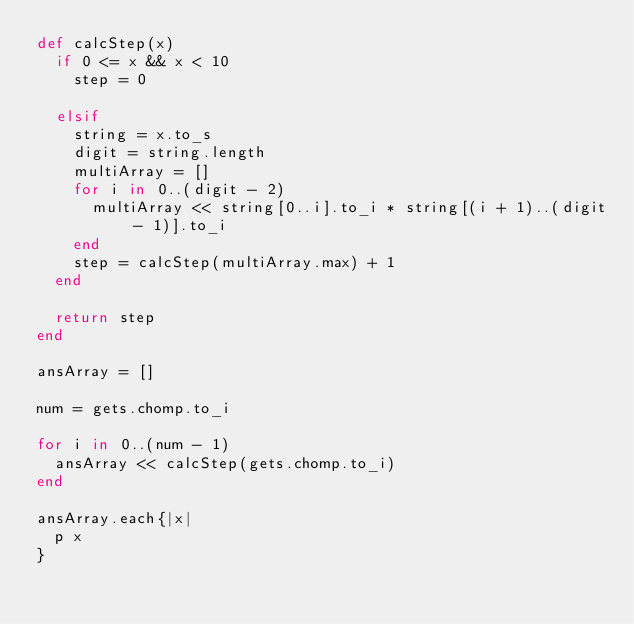Convert code to text. <code><loc_0><loc_0><loc_500><loc_500><_Ruby_>def calcStep(x)
  if 0 <= x && x < 10
    step = 0

  elsif
    string = x.to_s
    digit = string.length
    multiArray = []
    for i in 0..(digit - 2)
      multiArray << string[0..i].to_i * string[(i + 1)..(digit - 1)].to_i
    end
    step = calcStep(multiArray.max) + 1
  end
  
  return step
end

ansArray = []

num = gets.chomp.to_i

for i in 0..(num - 1)
  ansArray << calcStep(gets.chomp.to_i)
end

ansArray.each{|x|
  p x
}</code> 